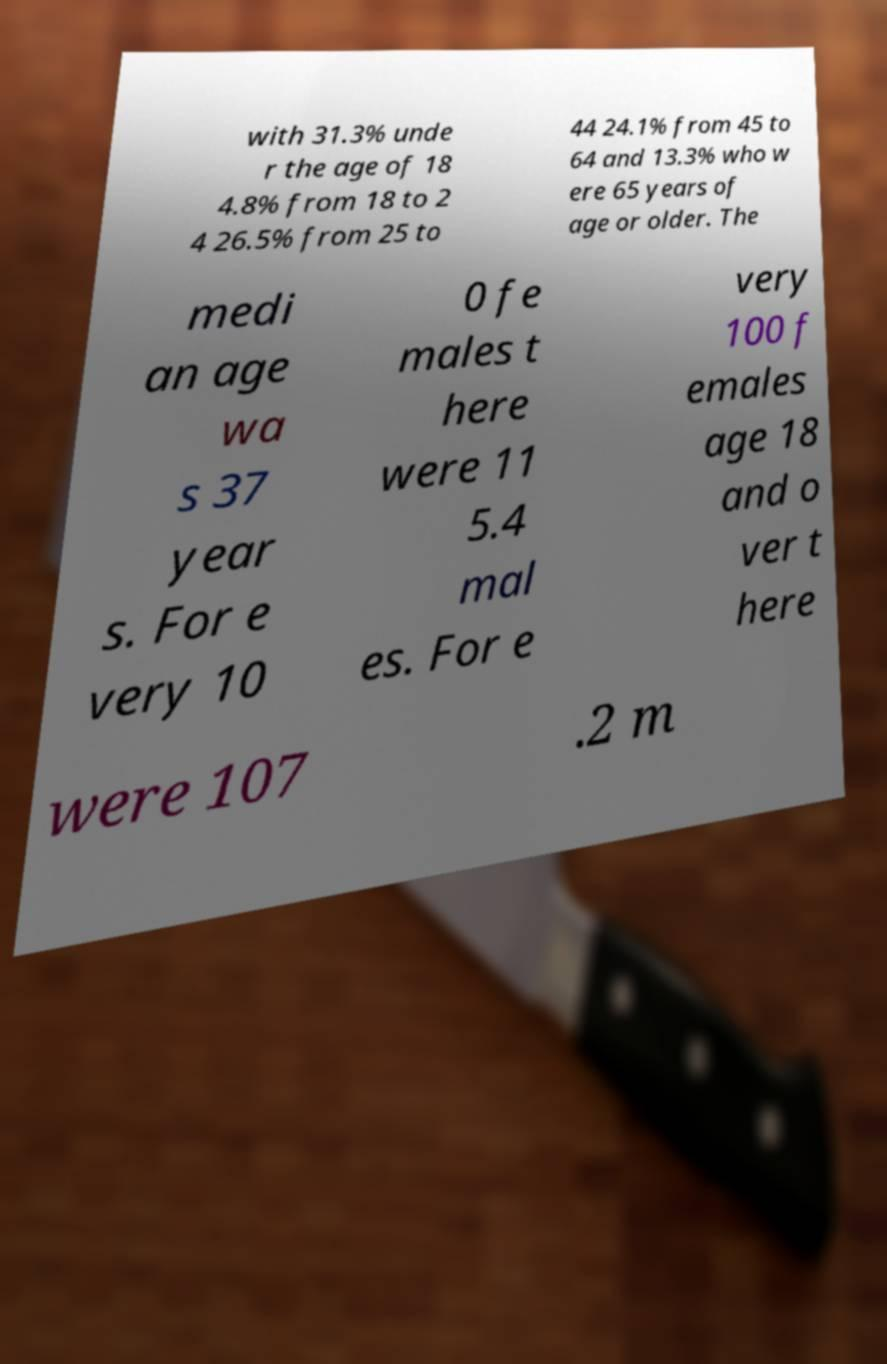Could you extract and type out the text from this image? with 31.3% unde r the age of 18 4.8% from 18 to 2 4 26.5% from 25 to 44 24.1% from 45 to 64 and 13.3% who w ere 65 years of age or older. The medi an age wa s 37 year s. For e very 10 0 fe males t here were 11 5.4 mal es. For e very 100 f emales age 18 and o ver t here were 107 .2 m 